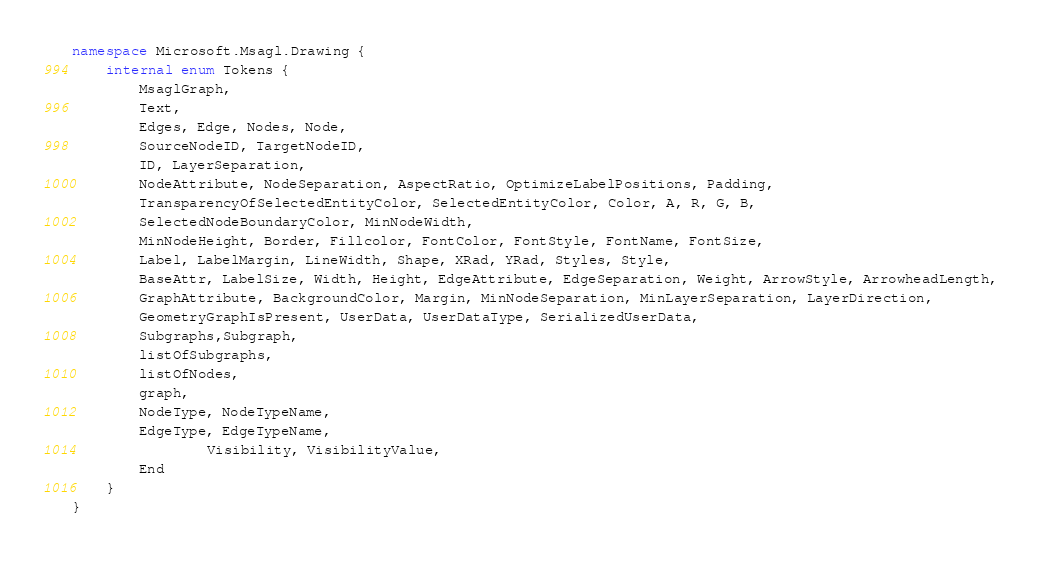Convert code to text. <code><loc_0><loc_0><loc_500><loc_500><_C#_>namespace Microsoft.Msagl.Drawing {
    internal enum Tokens {
        MsaglGraph,
        Text,
        Edges, Edge, Nodes, Node,
        SourceNodeID, TargetNodeID,
        ID, LayerSeparation,
        NodeAttribute, NodeSeparation, AspectRatio, OptimizeLabelPositions, Padding,
        TransparencyOfSelectedEntityColor, SelectedEntityColor, Color, A, R, G, B,
        SelectedNodeBoundaryColor, MinNodeWidth,
        MinNodeHeight, Border, Fillcolor, FontColor, FontStyle, FontName, FontSize,
        Label, LabelMargin, LineWidth, Shape, XRad, YRad, Styles, Style,
        BaseAttr, LabelSize, Width, Height, EdgeAttribute, EdgeSeparation, Weight, ArrowStyle, ArrowheadLength,
        GraphAttribute, BackgroundColor, Margin, MinNodeSeparation, MinLayerSeparation, LayerDirection,
        GeometryGraphIsPresent, UserData, UserDataType, SerializedUserData,
        Subgraphs,Subgraph,
        listOfSubgraphs,
        listOfNodes,
        graph,
        NodeType, NodeTypeName,
        EdgeType, EdgeTypeName,
				Visibility, VisibilityValue,
        End
    }
}
</code> 